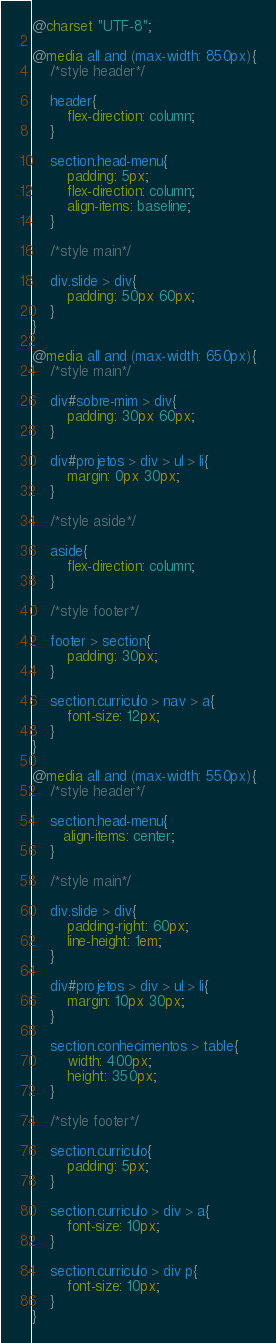<code> <loc_0><loc_0><loc_500><loc_500><_CSS_>@charset "UTF-8";

@media all and (max-width: 850px){
    /*style header*/

    header{
        flex-direction: column;
    }

    section.head-menu{
        padding: 5px;
        flex-direction: column;
        align-items: baseline;
    }

    /*style main*/

    div.slide > div{
        padding: 50px 60px;
    }
}

@media all and (max-width: 650px){
    /*style main*/

    div#sobre-mim > div{
        padding: 30px 60px;
    }

    div#projetos > div > ul > li{
        margin: 0px 30px;
    }

    /*style aside*/

    aside{
        flex-direction: column;
    }

    /*style footer*/

    footer > section{
        padding: 30px;
    }

    section.curriculo > nav > a{
        font-size: 12px;
    }
}

@media all and (max-width: 550px){
    /*style header*/

    section.head-menu{
       align-items: center;
    }

    /*style main*/

    div.slide > div{
        padding-right: 60px;
        line-height: 1em;
    }

    div#projetos > div > ul > li{
        margin: 10px 30px;
    }

    section.conhecimentos > table{
        width: 400px;
        height: 350px;
    }

    /*style footer*/

    section.curriculo{
        padding: 5px;
    }

    section.curriculo > div > a{
        font-size: 10px;
    }

    section.curriculo > div p{
        font-size: 10px;
    }
}</code> 